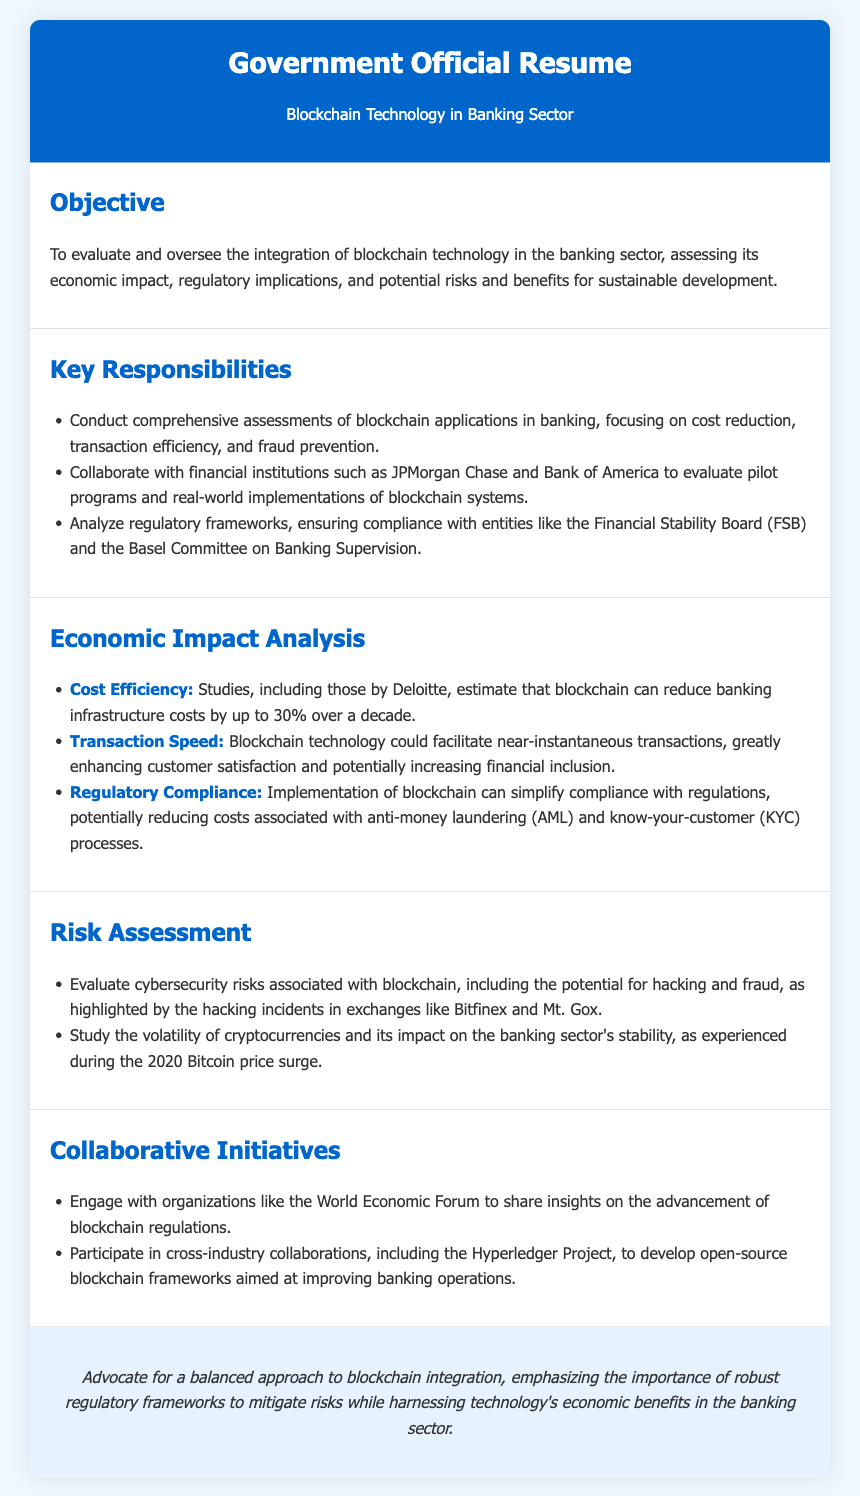What is the objective of the resume? The objective is to evaluate and oversee the integration of blockchain technology in the banking sector, assessing its economic impact, regulatory implications, and potential risks and benefits for sustainable development.
Answer: To evaluate and oversee the integration of blockchain technology in the banking sector What percentage can blockchain reduce banking infrastructure costs according to Deloitte? The document states that blockchain can reduce banking infrastructure costs by up to 30% over a decade according to studies by Deloitte.
Answer: 30% Which institutions are mentioned as collaborators? The resume mentions JPMorgan Chase and Bank of America as financial institutions with whom the official collaborates to evaluate pilot programs and real-world implementations of blockchain systems.
Answer: JPMorgan Chase and Bank of America What is a potential benefit relating to transaction speed? The document indicates that blockchain technology could facilitate near-instantaneous transactions, greatly enhancing customer satisfaction and potentially increasing financial inclusion.
Answer: Near-instantaneous transactions What key risk is associated with blockchain transactions? The resume highlights cybersecurity risks as a key concern, including the potential for hacking and fraud, specifically citing incidents in exchanges like Bitfinex and Mt. Gox.
Answer: Cybersecurity risks What collaborative initiative is mentioned in the document? The document mentions engagement with organizations like the World Economic Forum to share insights on the advancement of blockchain regulations as a collaborative initiative.
Answer: World Economic Forum What is emphasized in the conclusion of the resume? The conclusion advocates for a balanced approach to blockchain integration, emphasizing the importance of robust regulatory frameworks to mitigate risks while harnessing technology's economic benefits in the banking sector.
Answer: Robust regulatory frameworks What aspect of cryptocurrencies is studied for its impact on the banking sector? The resume states that the volatility of cryptocurrencies is studied for its impact on the banking sector's stability, as experienced during the 2020 Bitcoin price surge.
Answer: Volatility 